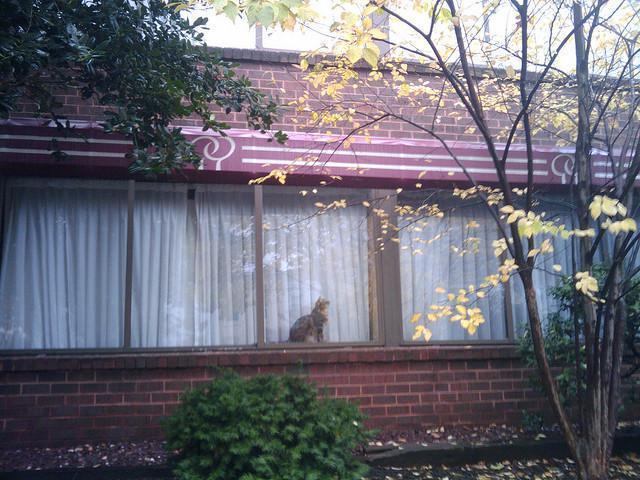How many levels does this bus contain?
Give a very brief answer. 0. 